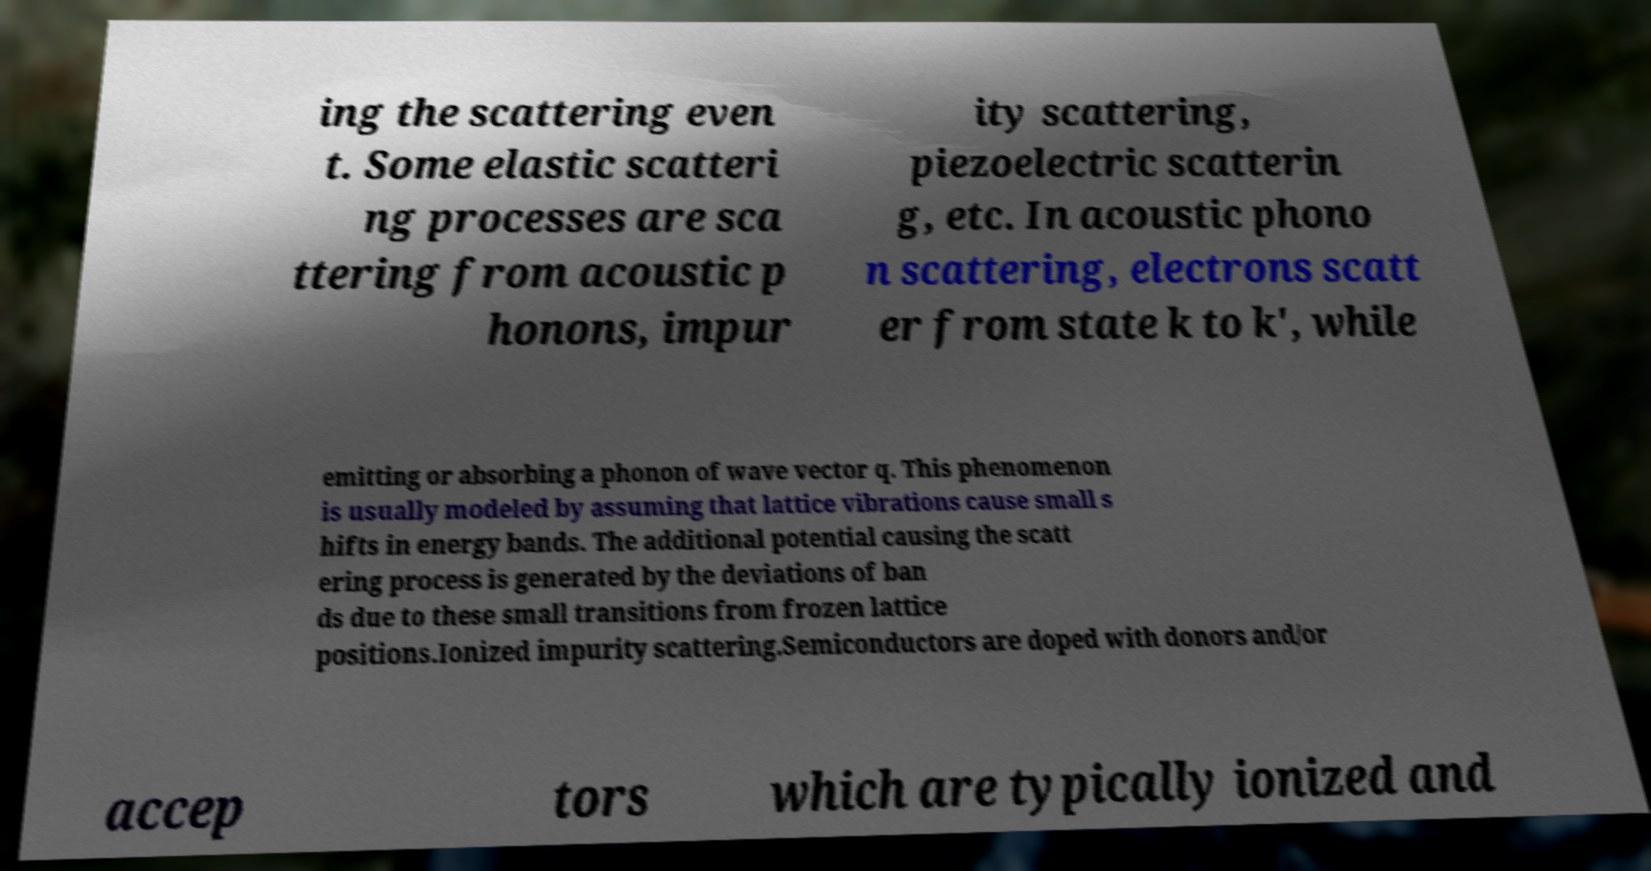Please read and relay the text visible in this image. What does it say? ing the scattering even t. Some elastic scatteri ng processes are sca ttering from acoustic p honons, impur ity scattering, piezoelectric scatterin g, etc. In acoustic phono n scattering, electrons scatt er from state k to k', while emitting or absorbing a phonon of wave vector q. This phenomenon is usually modeled by assuming that lattice vibrations cause small s hifts in energy bands. The additional potential causing the scatt ering process is generated by the deviations of ban ds due to these small transitions from frozen lattice positions.Ionized impurity scattering.Semiconductors are doped with donors and/or accep tors which are typically ionized and 